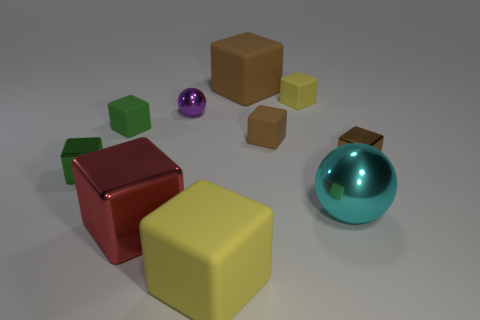What materials do the objects in the image seem to be made of? The objects in this image appear to exhibit various materials. The large yellow and brown cubes seem to possess a matte finish, likely representing a plastic or wooden material. The red cube has a reflective metallic sheen, suggesting it could be made from a metal or polished plastic. The two smaller green objects appear matte, perhaps indicative of a ceramic or painted wood, while the purple and turquoise spheres have reflective surfaces, illustrating perhaps a glass or glossy painted finish. 